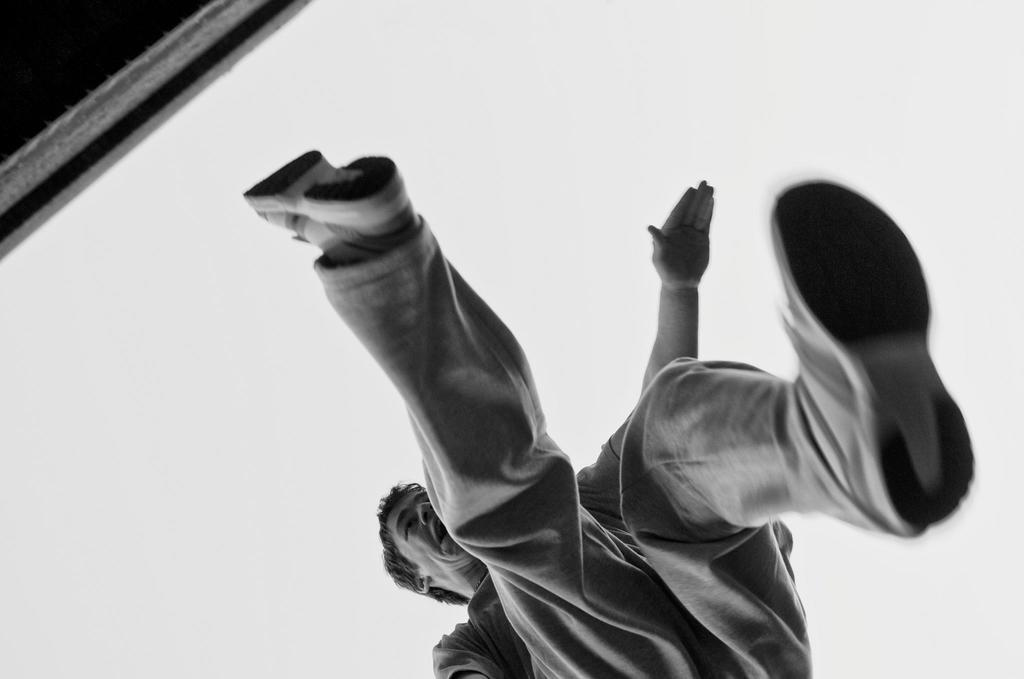What is the color scheme of the image? The image is black and white. Who is present in the image? There is a man in the image. What is the man doing in the image? The man is jumping. What can be seen in the background of the image? The sky is visible in the background of the image, and there is an object present. What type of music can be heard in the background of the image? There is no music present in the image, as it is a still photograph. How many rabbits are visible in the image? There are no rabbits present in the image. 